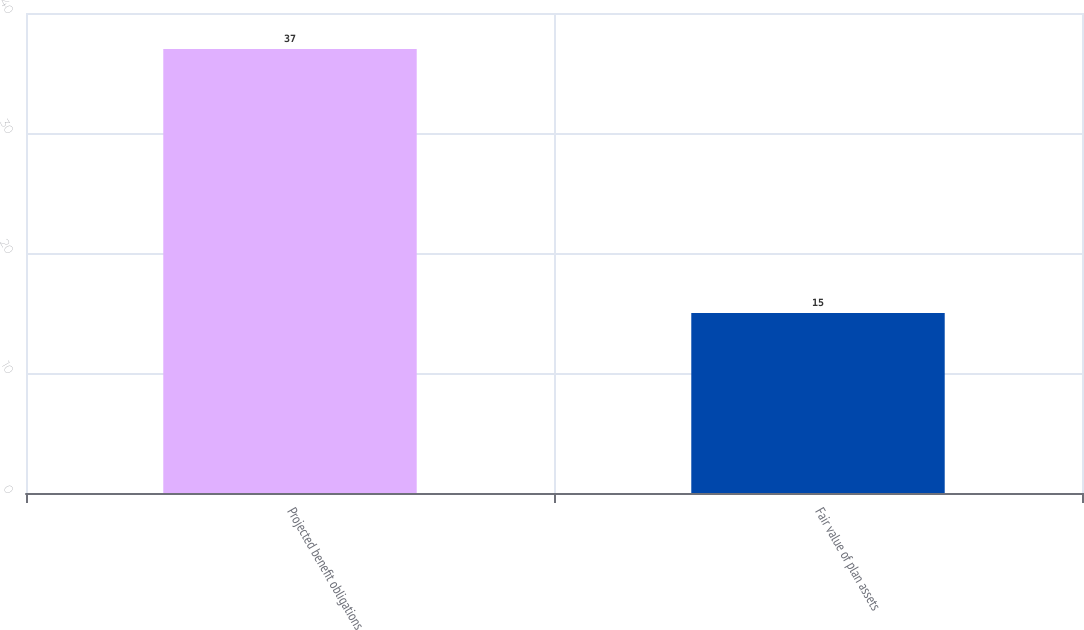Convert chart to OTSL. <chart><loc_0><loc_0><loc_500><loc_500><bar_chart><fcel>Projected benefit obligations<fcel>Fair value of plan assets<nl><fcel>37<fcel>15<nl></chart> 